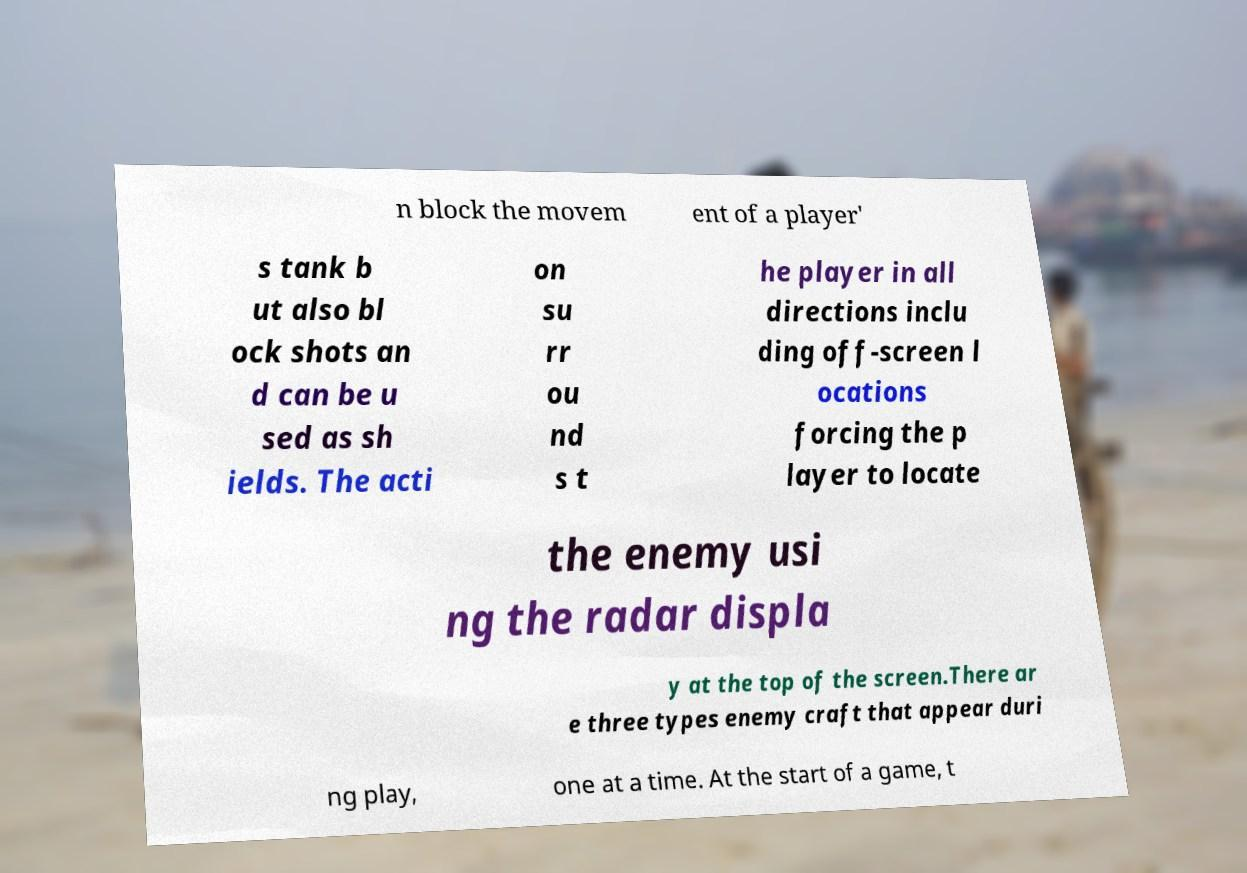Please identify and transcribe the text found in this image. n block the movem ent of a player' s tank b ut also bl ock shots an d can be u sed as sh ields. The acti on su rr ou nd s t he player in all directions inclu ding off-screen l ocations forcing the p layer to locate the enemy usi ng the radar displa y at the top of the screen.There ar e three types enemy craft that appear duri ng play, one at a time. At the start of a game, t 